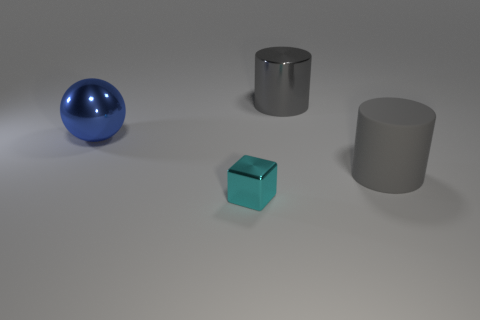How many gray cylinders must be subtracted to get 1 gray cylinders? 1 Subtract 0 yellow cylinders. How many objects are left? 4 Subtract all spheres. How many objects are left? 3 Subtract 1 cubes. How many cubes are left? 0 Subtract all red cylinders. Subtract all yellow cubes. How many cylinders are left? 2 Subtract all red spheres. Subtract all gray metal cylinders. How many objects are left? 3 Add 4 large gray metallic objects. How many large gray metallic objects are left? 5 Add 2 gray metal cylinders. How many gray metal cylinders exist? 3 Add 4 cyan metallic objects. How many objects exist? 8 